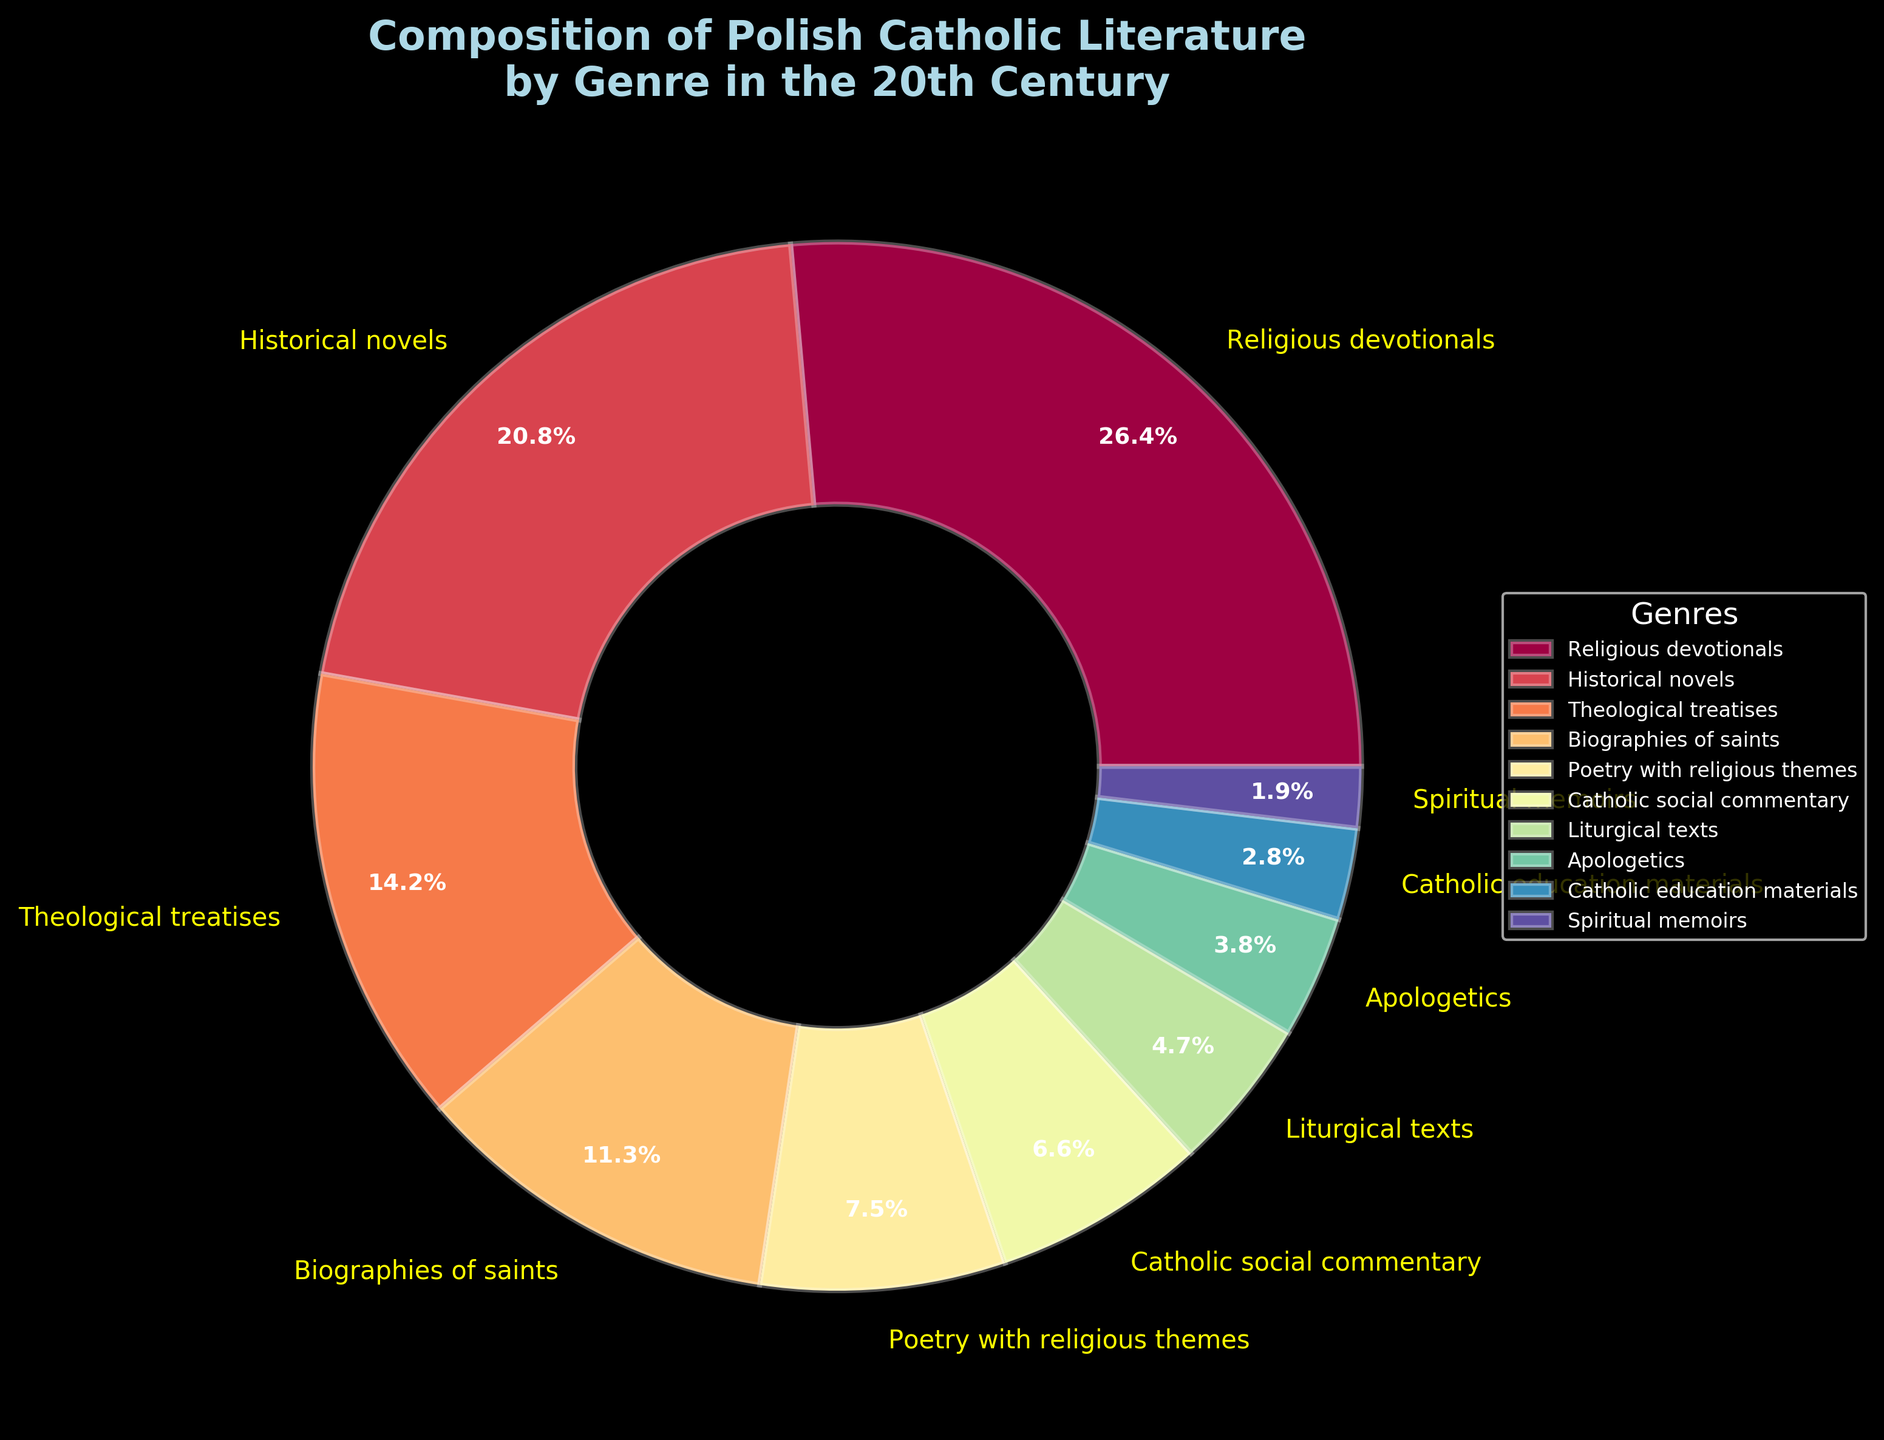What are the combined percentages of Religious devotionals and Biographies of saints? Add the percentages of Religious devotionals (28%) and Biographies of saints (12%). 28% + 12% = 40%
Answer: 40% Which genre has the smallest representation in Polish Catholic literature in the 20th century? Identify the genre with the smallest percentage. Spiritual memoirs have the smallest share with 2%.
Answer: Spiritual memoirs Is the percentage of Historical novels greater than the combination of Apologetics and Liturgical texts? Compare the percentage of Historical novels (22%) to the sum of Apologetics (4%) and Liturgical texts (5%). 22% is greater than 4% + 5% = 9%.
Answer: Yes Between Catholic social commentary and Poetry with religious themes, which one has a higher percentage and by how much? Compare Catholic social commentary (7%) with Poetry with religious themes (8%) and calculate the difference. 8% - 7% = 1%.
Answer: Poetry with religious themes by 1% How much more do Religious devotionals contribute to the composition compared to Catholic education materials? Subtract the percentage of Catholic education materials (3%) from Religious devotionals (28%). 28% - 3% = 25%.
Answer: 25% Which genre in Polish Catholic literature is represented by the color closest to yellow? Identify the color closest to yellow in the pie chart. It's the label for Religious devotionals.
Answer: Religious devotionals If you combine the percentages of Theological treatises and Catholic education materials, does it exceed Religious devotionals? Calculate the sum of Theological treatises (15%) and Catholic education materials (3%), then compare it to Religious devotionals (28%). 15% + 3% = 18%, which is less than 28%.
Answer: No What is the total percentage of genres that individually contribute less than 10%? Calculate the sum of genres with less than 10%: Poetry with religious themes (8%), Catholic social commentary (7%), Liturgical texts (5%), Apologetics (4%), Catholic education materials (3%), Spiritual memoirs (2%). 8% + 7% + 5% + 4% + 3% + 2% = 29%.
Answer: 29% 